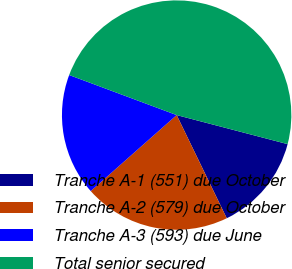Convert chart. <chart><loc_0><loc_0><loc_500><loc_500><pie_chart><fcel>Tranche A-1 (551) due October<fcel>Tranche A-2 (579) due October<fcel>Tranche A-3 (593) due June<fcel>Total senior secured<nl><fcel>13.73%<fcel>20.67%<fcel>17.2%<fcel>48.4%<nl></chart> 